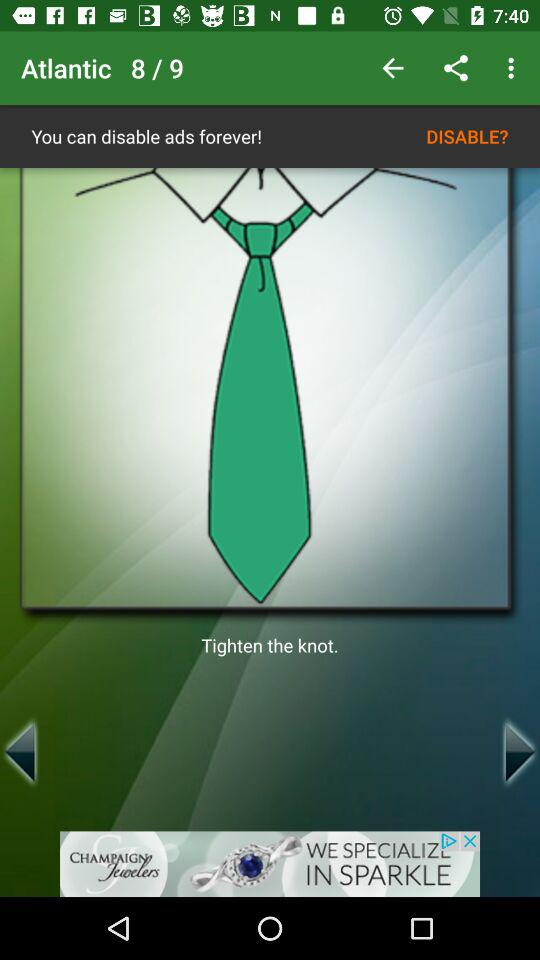What is the current image number? The current image number is 8. 